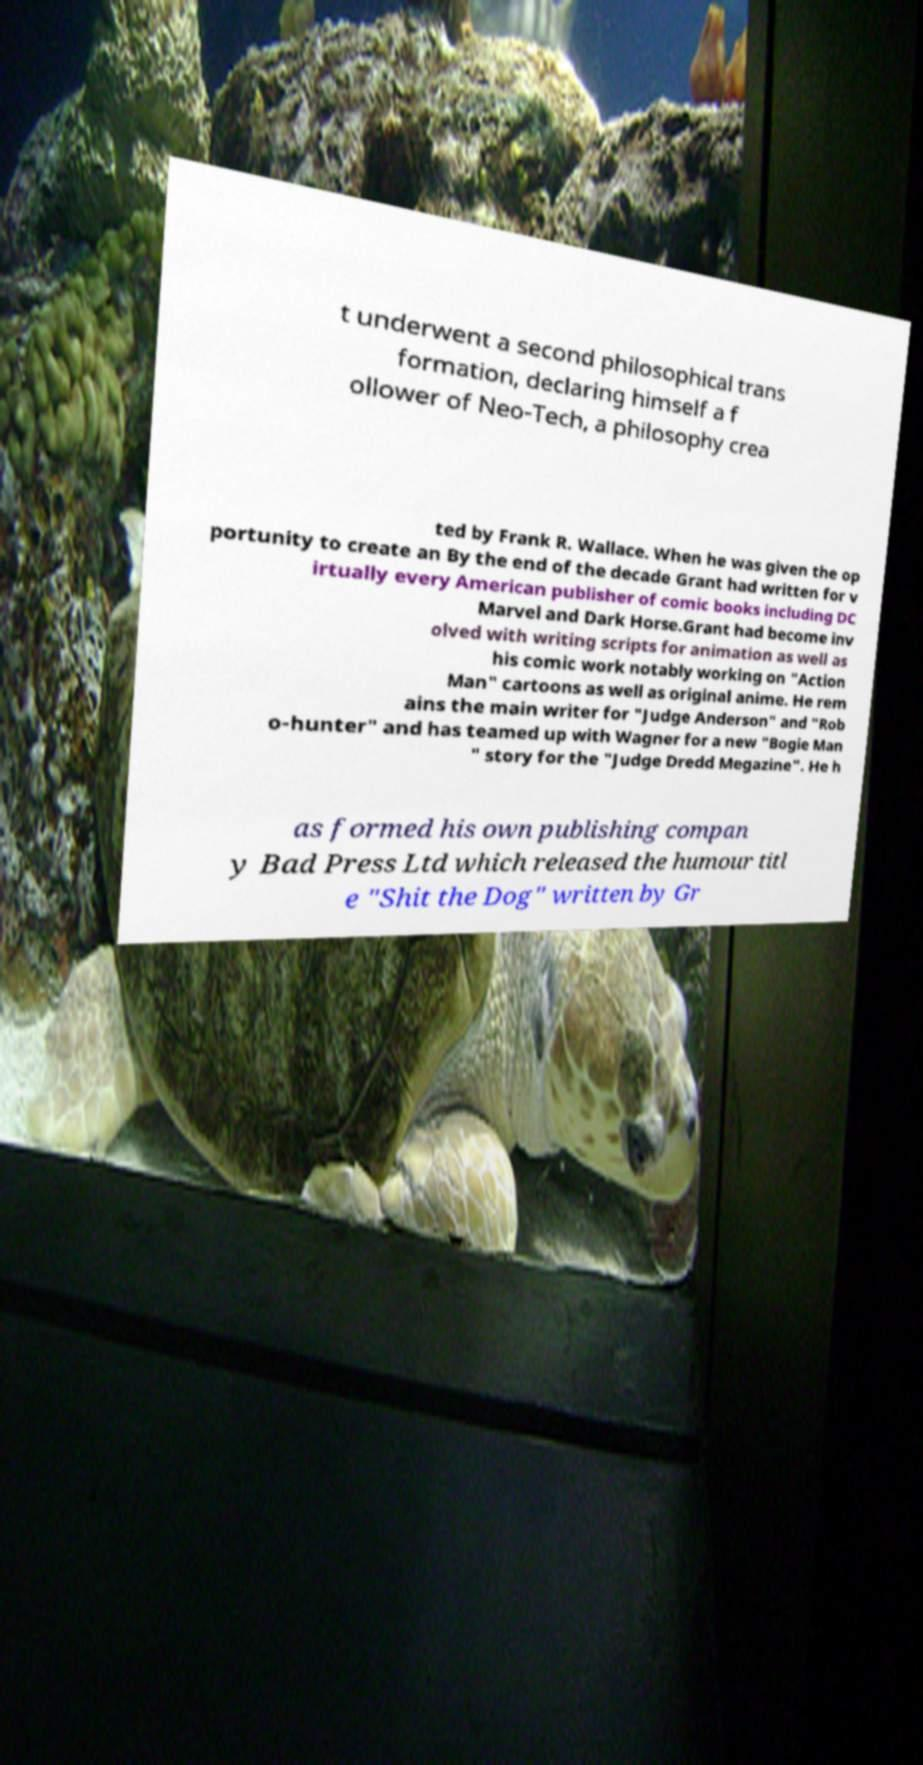Can you accurately transcribe the text from the provided image for me? t underwent a second philosophical trans formation, declaring himself a f ollower of Neo-Tech, a philosophy crea ted by Frank R. Wallace. When he was given the op portunity to create an By the end of the decade Grant had written for v irtually every American publisher of comic books including DC Marvel and Dark Horse.Grant had become inv olved with writing scripts for animation as well as his comic work notably working on "Action Man" cartoons as well as original anime. He rem ains the main writer for "Judge Anderson" and "Rob o-hunter" and has teamed up with Wagner for a new "Bogie Man " story for the "Judge Dredd Megazine". He h as formed his own publishing compan y Bad Press Ltd which released the humour titl e "Shit the Dog" written by Gr 